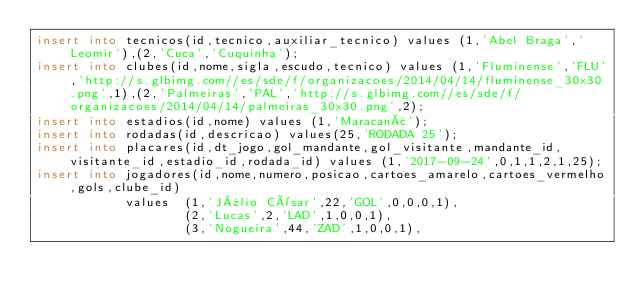<code> <loc_0><loc_0><loc_500><loc_500><_SQL_>insert into tecnicos(id,tecnico,auxiliar_tecnico) values (1,'Abel Braga','Leomir'),(2,'Cuca','Cuquinha');
insert into clubes(id,nome,sigla,escudo,tecnico) values (1,'Fluminense','FLU','http://s.glbimg.com//es/sde/f/organizacoes/2014/04/14/fluminense_30x30.png',1),(2,'Palmeiras','PAL','http://s.glbimg.com//es/sde/f/organizacoes/2014/04/14/palmeiras_30x30.png',2);
insert into estadios(id,nome) values (1,'Maracanã');
insert into rodadas(id,descricao) values(25,'RODADA 25');
insert into placares(id,dt_jogo,gol_mandante,gol_visitante,mandante_id,visitante_id,estadio_id,rodada_id) values (1,'2017-09-24',0,1,1,2,1,25);
insert into jogadores(id,nome,numero,posicao,cartoes_amarelo,cartoes_vermelho,gols,clube_id) 
			values 	(1,'Júlio César',22,'GOL',0,0,0,1),
					(2,'Lucas',2,'LAD',1,0,0,1),
                    (3,'Nogueira',44,'ZAD',1,0,0,1),</code> 